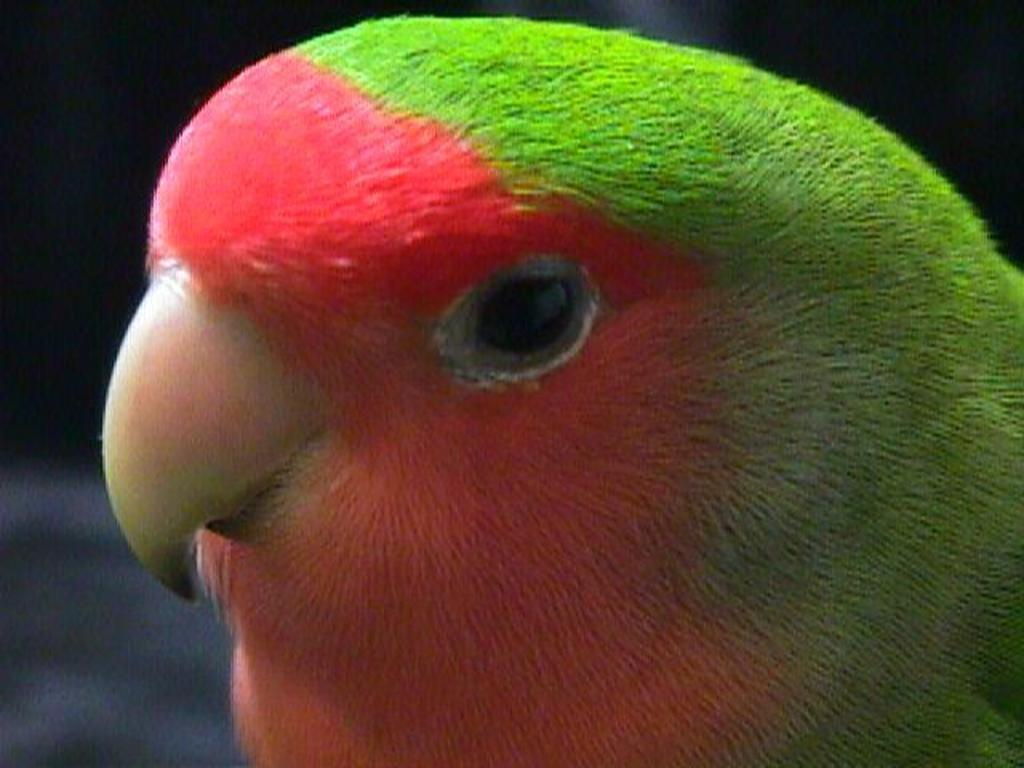What type of animal is in the picture? There is a bird in the picture. Can you describe the bird's appearance? The bird resembles a parrot and has green and red colors. How would you describe the background of the image? The background of the image is blurred. What time of day is it in the image, specifically in the afternoon? The time of day is not mentioned or depicted in the image, so it cannot be determined whether it is in the afternoon or not. 